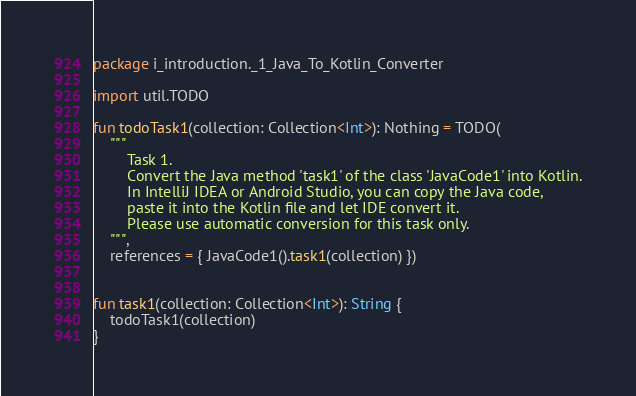<code> <loc_0><loc_0><loc_500><loc_500><_Kotlin_>package i_introduction._1_Java_To_Kotlin_Converter

import util.TODO

fun todoTask1(collection: Collection<Int>): Nothing = TODO(
    """
        Task 1.
        Convert the Java method 'task1' of the class 'JavaCode1' into Kotlin.
        In IntelliJ IDEA or Android Studio, you can copy the Java code,
        paste it into the Kotlin file and let IDE convert it.
        Please use automatic conversion for this task only.
    """,
    references = { JavaCode1().task1(collection) })


fun task1(collection: Collection<Int>): String {
    todoTask1(collection)
}</code> 